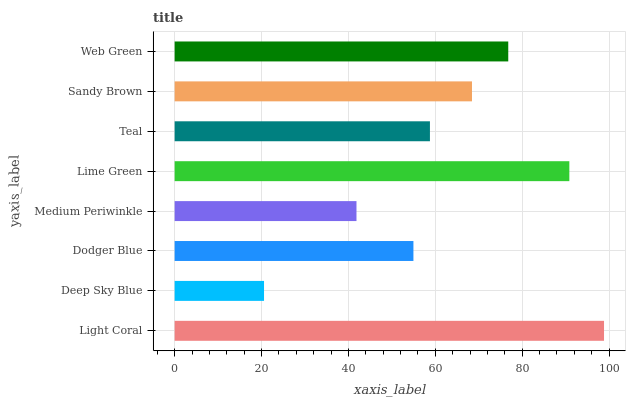Is Deep Sky Blue the minimum?
Answer yes or no. Yes. Is Light Coral the maximum?
Answer yes or no. Yes. Is Dodger Blue the minimum?
Answer yes or no. No. Is Dodger Blue the maximum?
Answer yes or no. No. Is Dodger Blue greater than Deep Sky Blue?
Answer yes or no. Yes. Is Deep Sky Blue less than Dodger Blue?
Answer yes or no. Yes. Is Deep Sky Blue greater than Dodger Blue?
Answer yes or no. No. Is Dodger Blue less than Deep Sky Blue?
Answer yes or no. No. Is Sandy Brown the high median?
Answer yes or no. Yes. Is Teal the low median?
Answer yes or no. Yes. Is Teal the high median?
Answer yes or no. No. Is Sandy Brown the low median?
Answer yes or no. No. 